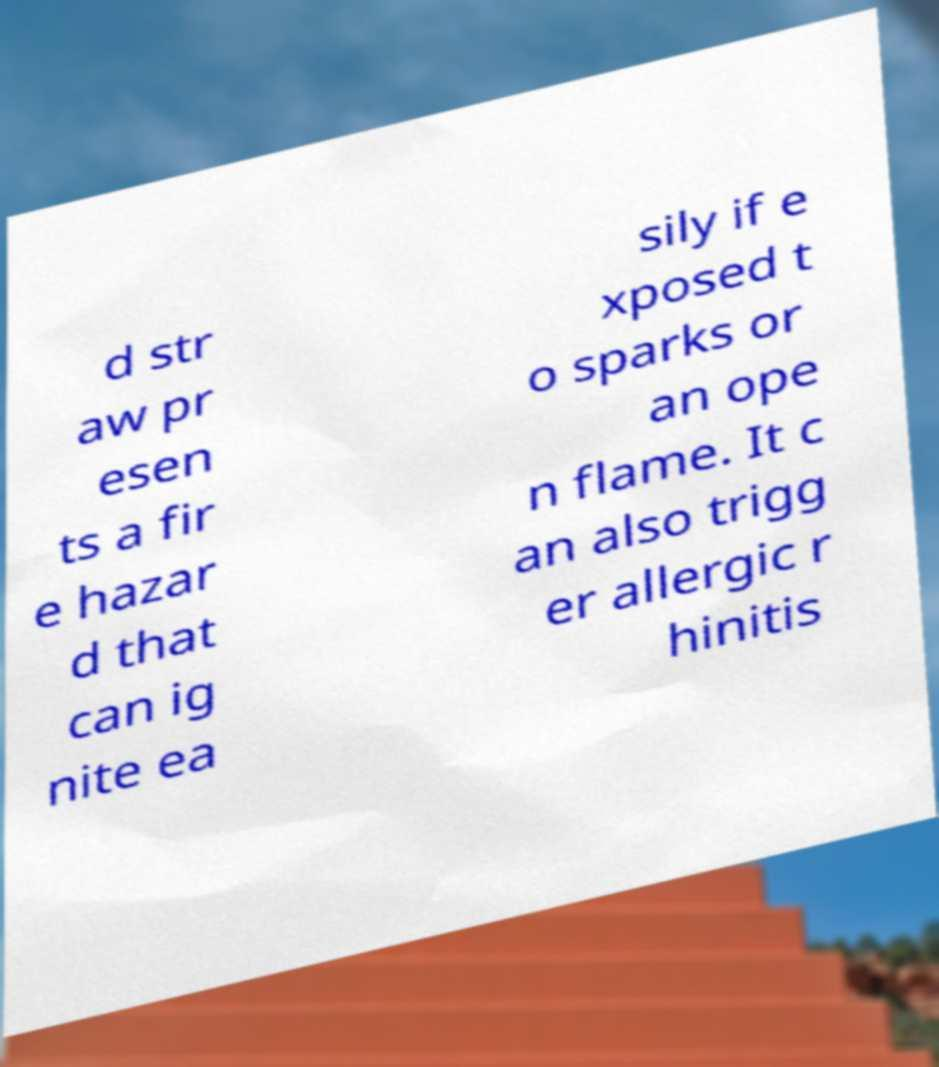Can you accurately transcribe the text from the provided image for me? d str aw pr esen ts a fir e hazar d that can ig nite ea sily if e xposed t o sparks or an ope n flame. It c an also trigg er allergic r hinitis 